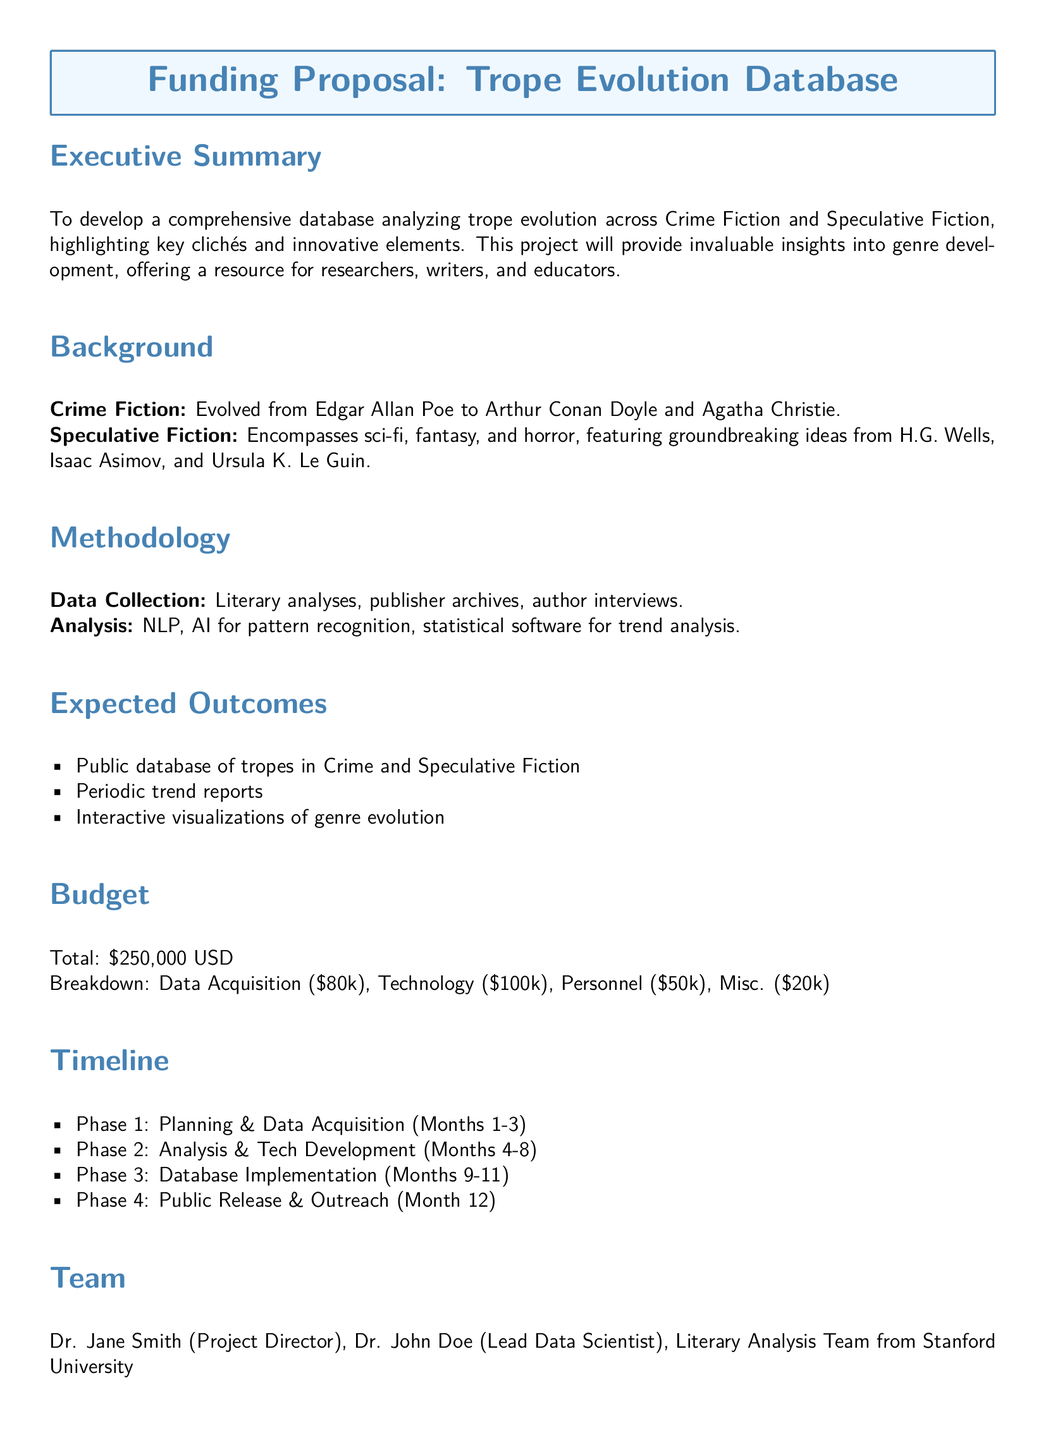what is the total budget for the project? The total budget is explicitly stated in the document as \$250,000 USD.
Answer: \$250,000 USD who is the project director? The project director's name is provided in the document under the Team section.
Answer: Dr. Jane Smith what are the phases included in the timeline? The document lists the phases in the timeline section, which include Planning & Data Acquisition, Analysis & Tech Development, Database Implementation, and Public Release & Outreach.
Answer: 4 what is the main focus of the proposal? The executive summary clarifies that the main focus is to develop a comprehensive database analyzing trope evolution across Crime Fiction and Speculative Fiction.
Answer: Trope evolution database which technology is planned for the project? The technology budget category in the document indicates that \$100,000 is allocated for technology-related expenses.
Answer: \$100,000 how many members are on the literary analysis team? The document mentions a team but does not specify a number of members; thus reasoning is required based on context.
Answer: Unspecified what is the expected outcome related to visualizations? The expected outcomes section states that interactive visualizations of genre evolution will be produced.
Answer: Interactive visualizations who are the notable authors mentioned for Crime Fiction? The background section of the proposal lists key figures in the evolution of Crime Fiction, specifically mentioning Edgar Allan Poe, Arthur Conan Doyle, and Agatha Christie.
Answer: Edgar Allan Poe, Arthur Conan Doyle, Agatha Christie 